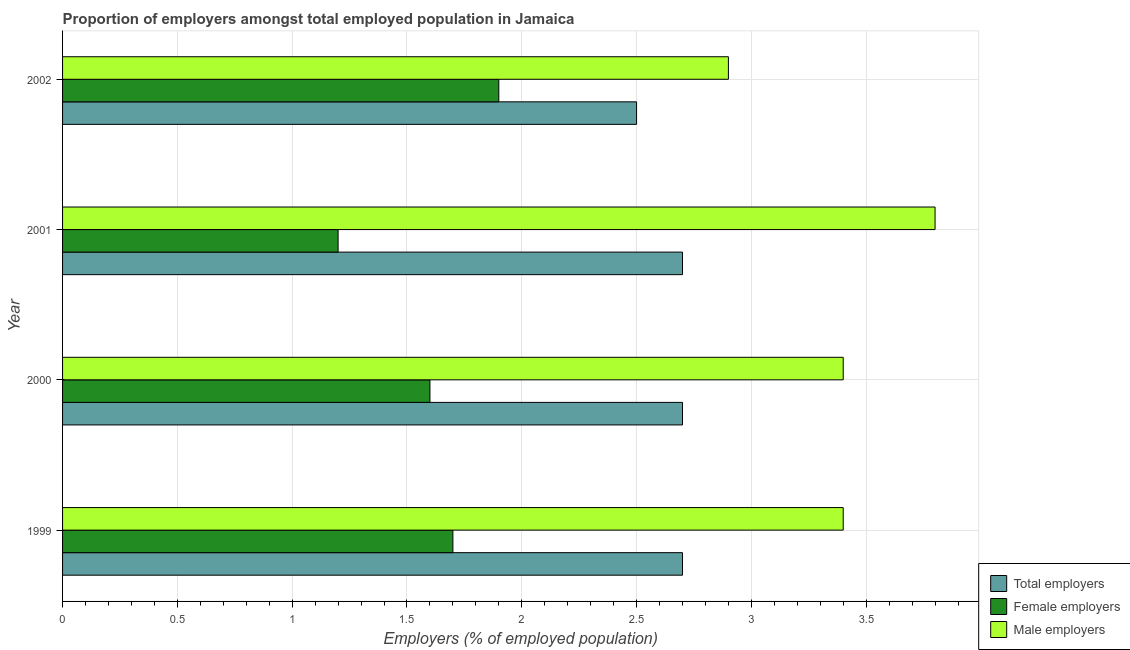Are the number of bars on each tick of the Y-axis equal?
Offer a very short reply. Yes. How many bars are there on the 1st tick from the top?
Your answer should be very brief. 3. How many bars are there on the 2nd tick from the bottom?
Your answer should be very brief. 3. In how many cases, is the number of bars for a given year not equal to the number of legend labels?
Make the answer very short. 0. What is the percentage of female employers in 2002?
Give a very brief answer. 1.9. Across all years, what is the maximum percentage of female employers?
Provide a succinct answer. 1.9. Across all years, what is the minimum percentage of female employers?
Provide a short and direct response. 1.2. In which year was the percentage of total employers minimum?
Offer a terse response. 2002. What is the total percentage of female employers in the graph?
Ensure brevity in your answer.  6.4. What is the difference between the percentage of female employers in 2002 and the percentage of male employers in 2001?
Provide a short and direct response. -1.9. What is the average percentage of male employers per year?
Ensure brevity in your answer.  3.38. In how many years, is the percentage of total employers greater than 0.9 %?
Your answer should be very brief. 4. Is the percentage of male employers in 2000 less than that in 2002?
Make the answer very short. No. What is the difference between the highest and the second highest percentage of male employers?
Make the answer very short. 0.4. What is the difference between the highest and the lowest percentage of male employers?
Your response must be concise. 0.9. In how many years, is the percentage of total employers greater than the average percentage of total employers taken over all years?
Give a very brief answer. 3. What does the 2nd bar from the top in 2002 represents?
Make the answer very short. Female employers. What does the 3rd bar from the bottom in 2000 represents?
Give a very brief answer. Male employers. How many bars are there?
Offer a very short reply. 12. Where does the legend appear in the graph?
Give a very brief answer. Bottom right. How are the legend labels stacked?
Your response must be concise. Vertical. What is the title of the graph?
Provide a succinct answer. Proportion of employers amongst total employed population in Jamaica. What is the label or title of the X-axis?
Your answer should be very brief. Employers (% of employed population). What is the Employers (% of employed population) in Total employers in 1999?
Ensure brevity in your answer.  2.7. What is the Employers (% of employed population) in Female employers in 1999?
Offer a very short reply. 1.7. What is the Employers (% of employed population) in Male employers in 1999?
Provide a succinct answer. 3.4. What is the Employers (% of employed population) in Total employers in 2000?
Provide a short and direct response. 2.7. What is the Employers (% of employed population) in Female employers in 2000?
Give a very brief answer. 1.6. What is the Employers (% of employed population) of Male employers in 2000?
Provide a succinct answer. 3.4. What is the Employers (% of employed population) of Total employers in 2001?
Provide a short and direct response. 2.7. What is the Employers (% of employed population) of Female employers in 2001?
Your response must be concise. 1.2. What is the Employers (% of employed population) of Male employers in 2001?
Provide a succinct answer. 3.8. What is the Employers (% of employed population) in Female employers in 2002?
Make the answer very short. 1.9. What is the Employers (% of employed population) of Male employers in 2002?
Give a very brief answer. 2.9. Across all years, what is the maximum Employers (% of employed population) in Total employers?
Provide a short and direct response. 2.7. Across all years, what is the maximum Employers (% of employed population) in Female employers?
Offer a very short reply. 1.9. Across all years, what is the maximum Employers (% of employed population) of Male employers?
Keep it short and to the point. 3.8. Across all years, what is the minimum Employers (% of employed population) in Total employers?
Make the answer very short. 2.5. Across all years, what is the minimum Employers (% of employed population) of Female employers?
Offer a terse response. 1.2. Across all years, what is the minimum Employers (% of employed population) in Male employers?
Provide a short and direct response. 2.9. What is the total Employers (% of employed population) in Male employers in the graph?
Offer a very short reply. 13.5. What is the difference between the Employers (% of employed population) in Total employers in 1999 and that in 2000?
Your response must be concise. 0. What is the difference between the Employers (% of employed population) of Female employers in 1999 and that in 2000?
Offer a terse response. 0.1. What is the difference between the Employers (% of employed population) of Total employers in 1999 and that in 2001?
Ensure brevity in your answer.  0. What is the difference between the Employers (% of employed population) of Female employers in 1999 and that in 2001?
Your answer should be compact. 0.5. What is the difference between the Employers (% of employed population) of Male employers in 1999 and that in 2001?
Offer a terse response. -0.4. What is the difference between the Employers (% of employed population) in Total employers in 2000 and that in 2001?
Give a very brief answer. 0. What is the difference between the Employers (% of employed population) of Male employers in 2000 and that in 2001?
Offer a very short reply. -0.4. What is the difference between the Employers (% of employed population) of Female employers in 2000 and that in 2002?
Give a very brief answer. -0.3. What is the difference between the Employers (% of employed population) in Male employers in 2001 and that in 2002?
Your answer should be compact. 0.9. What is the difference between the Employers (% of employed population) of Total employers in 1999 and the Employers (% of employed population) of Female employers in 2000?
Give a very brief answer. 1.1. What is the difference between the Employers (% of employed population) in Total employers in 1999 and the Employers (% of employed population) in Male employers in 2001?
Make the answer very short. -1.1. What is the difference between the Employers (% of employed population) of Total employers in 1999 and the Employers (% of employed population) of Male employers in 2002?
Your response must be concise. -0.2. What is the difference between the Employers (% of employed population) in Total employers in 2000 and the Employers (% of employed population) in Male employers in 2001?
Your response must be concise. -1.1. What is the difference between the Employers (% of employed population) of Female employers in 2000 and the Employers (% of employed population) of Male employers in 2001?
Offer a terse response. -2.2. What is the difference between the Employers (% of employed population) in Total employers in 2000 and the Employers (% of employed population) in Female employers in 2002?
Give a very brief answer. 0.8. What is the difference between the Employers (% of employed population) of Female employers in 2001 and the Employers (% of employed population) of Male employers in 2002?
Your answer should be very brief. -1.7. What is the average Employers (% of employed population) in Total employers per year?
Provide a short and direct response. 2.65. What is the average Employers (% of employed population) in Male employers per year?
Provide a short and direct response. 3.38. In the year 1999, what is the difference between the Employers (% of employed population) of Total employers and Employers (% of employed population) of Male employers?
Your response must be concise. -0.7. In the year 1999, what is the difference between the Employers (% of employed population) of Female employers and Employers (% of employed population) of Male employers?
Ensure brevity in your answer.  -1.7. In the year 2000, what is the difference between the Employers (% of employed population) of Total employers and Employers (% of employed population) of Female employers?
Give a very brief answer. 1.1. In the year 2000, what is the difference between the Employers (% of employed population) of Total employers and Employers (% of employed population) of Male employers?
Your answer should be very brief. -0.7. In the year 2000, what is the difference between the Employers (% of employed population) of Female employers and Employers (% of employed population) of Male employers?
Offer a terse response. -1.8. In the year 2001, what is the difference between the Employers (% of employed population) in Total employers and Employers (% of employed population) in Male employers?
Ensure brevity in your answer.  -1.1. In the year 2001, what is the difference between the Employers (% of employed population) in Female employers and Employers (% of employed population) in Male employers?
Provide a succinct answer. -2.6. In the year 2002, what is the difference between the Employers (% of employed population) of Total employers and Employers (% of employed population) of Female employers?
Give a very brief answer. 0.6. In the year 2002, what is the difference between the Employers (% of employed population) of Female employers and Employers (% of employed population) of Male employers?
Provide a succinct answer. -1. What is the ratio of the Employers (% of employed population) in Female employers in 1999 to that in 2000?
Ensure brevity in your answer.  1.06. What is the ratio of the Employers (% of employed population) in Total employers in 1999 to that in 2001?
Offer a very short reply. 1. What is the ratio of the Employers (% of employed population) in Female employers in 1999 to that in 2001?
Offer a terse response. 1.42. What is the ratio of the Employers (% of employed population) of Male employers in 1999 to that in 2001?
Keep it short and to the point. 0.89. What is the ratio of the Employers (% of employed population) of Female employers in 1999 to that in 2002?
Make the answer very short. 0.89. What is the ratio of the Employers (% of employed population) of Male employers in 1999 to that in 2002?
Keep it short and to the point. 1.17. What is the ratio of the Employers (% of employed population) in Total employers in 2000 to that in 2001?
Your answer should be very brief. 1. What is the ratio of the Employers (% of employed population) of Male employers in 2000 to that in 2001?
Ensure brevity in your answer.  0.89. What is the ratio of the Employers (% of employed population) in Female employers in 2000 to that in 2002?
Provide a short and direct response. 0.84. What is the ratio of the Employers (% of employed population) in Male employers in 2000 to that in 2002?
Your answer should be very brief. 1.17. What is the ratio of the Employers (% of employed population) of Total employers in 2001 to that in 2002?
Your answer should be compact. 1.08. What is the ratio of the Employers (% of employed population) in Female employers in 2001 to that in 2002?
Give a very brief answer. 0.63. What is the ratio of the Employers (% of employed population) in Male employers in 2001 to that in 2002?
Make the answer very short. 1.31. What is the difference between the highest and the second highest Employers (% of employed population) of Female employers?
Your response must be concise. 0.2. What is the difference between the highest and the lowest Employers (% of employed population) in Total employers?
Offer a terse response. 0.2. 